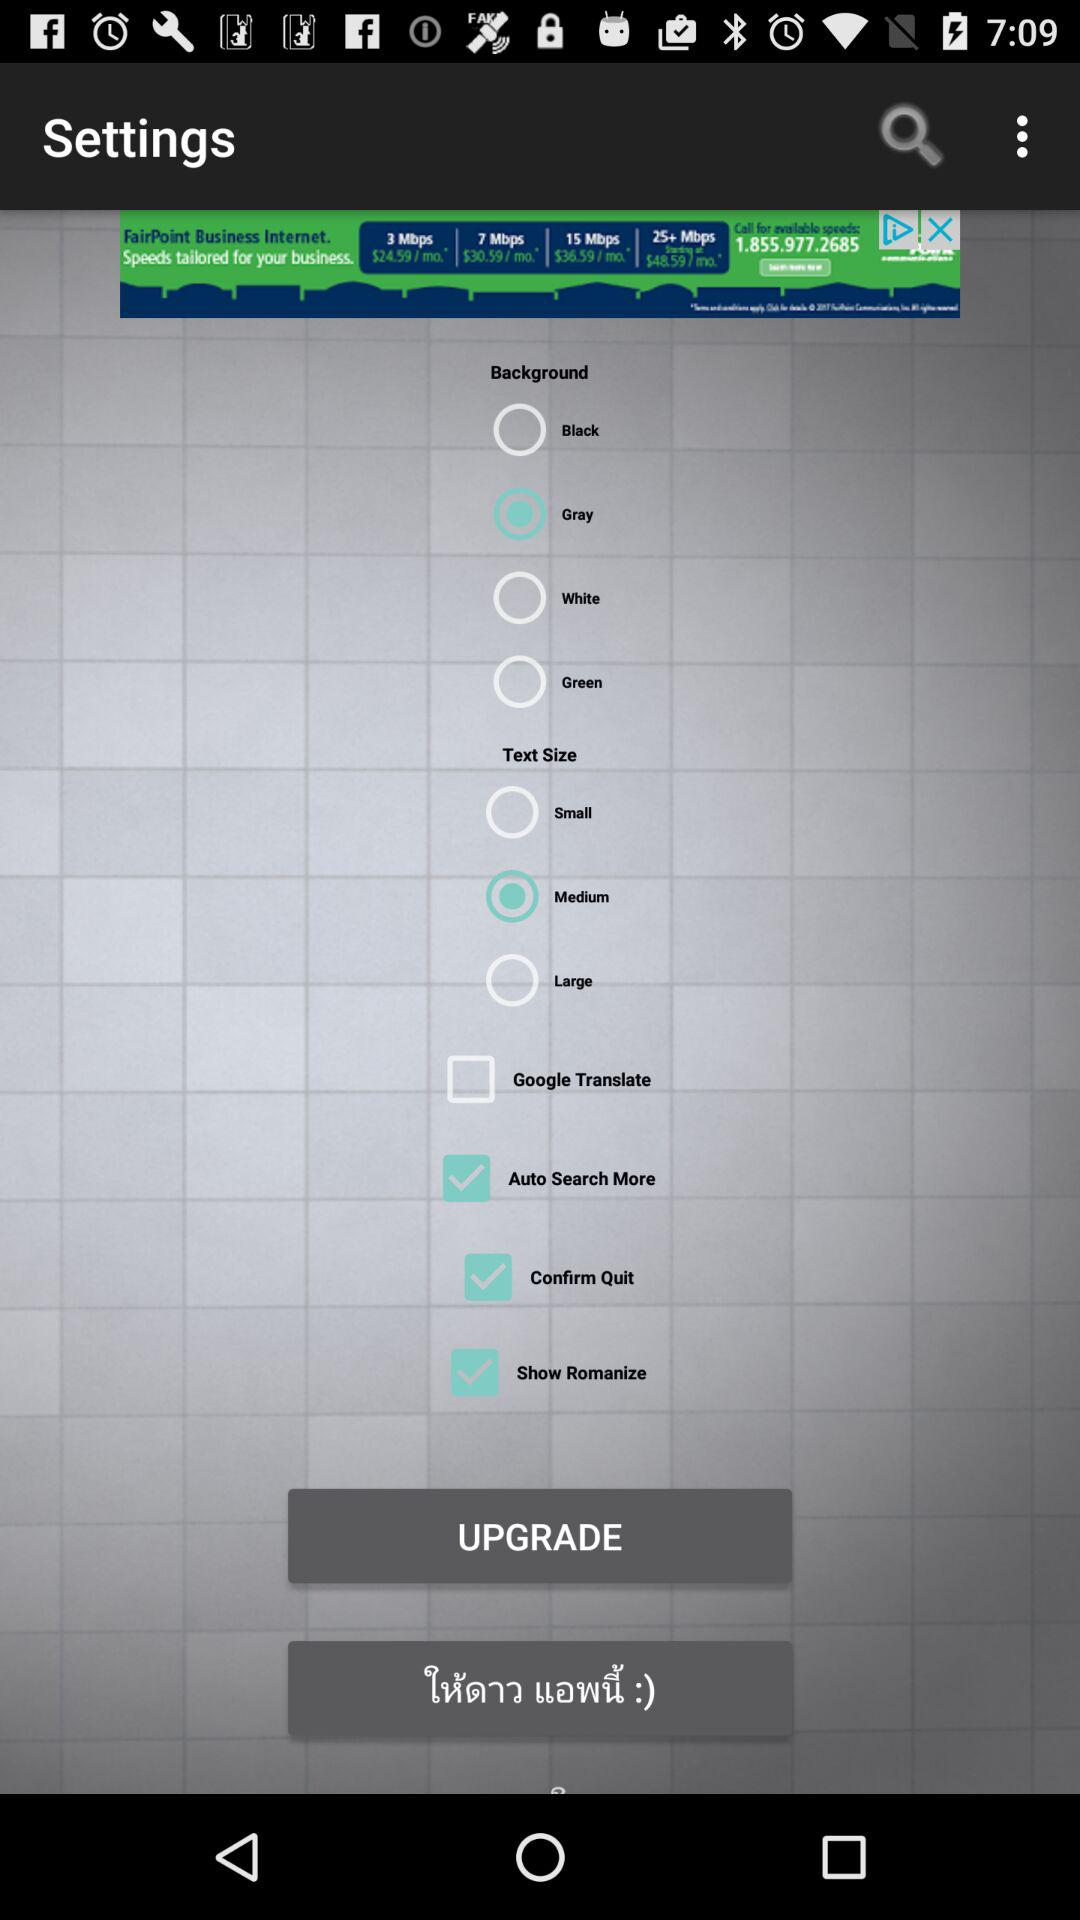What is the status of "Confirm Quit"? The status is on. 